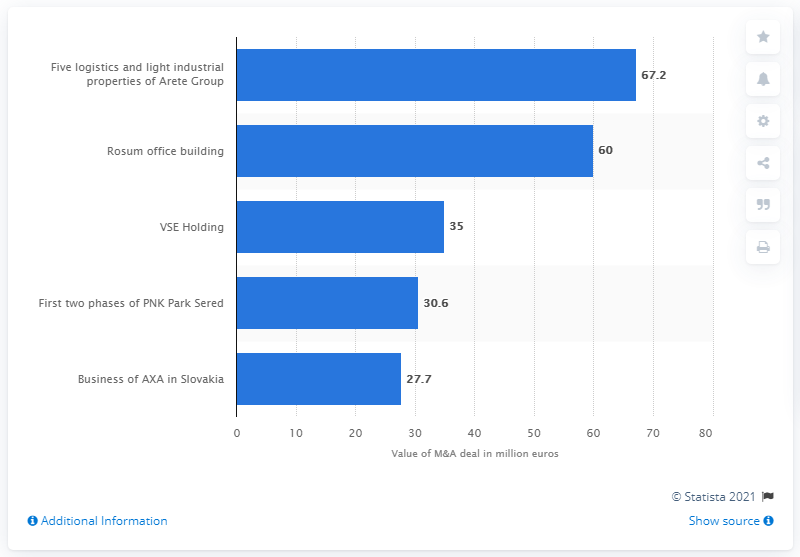Indicate a few pertinent items in this graphic. The acquisition of five logistics and light industrial properties by Arete Group was valued at 60... UNIQA Insurance Group had a stake of 27.7% in the business of AXA as of [DATE]. 